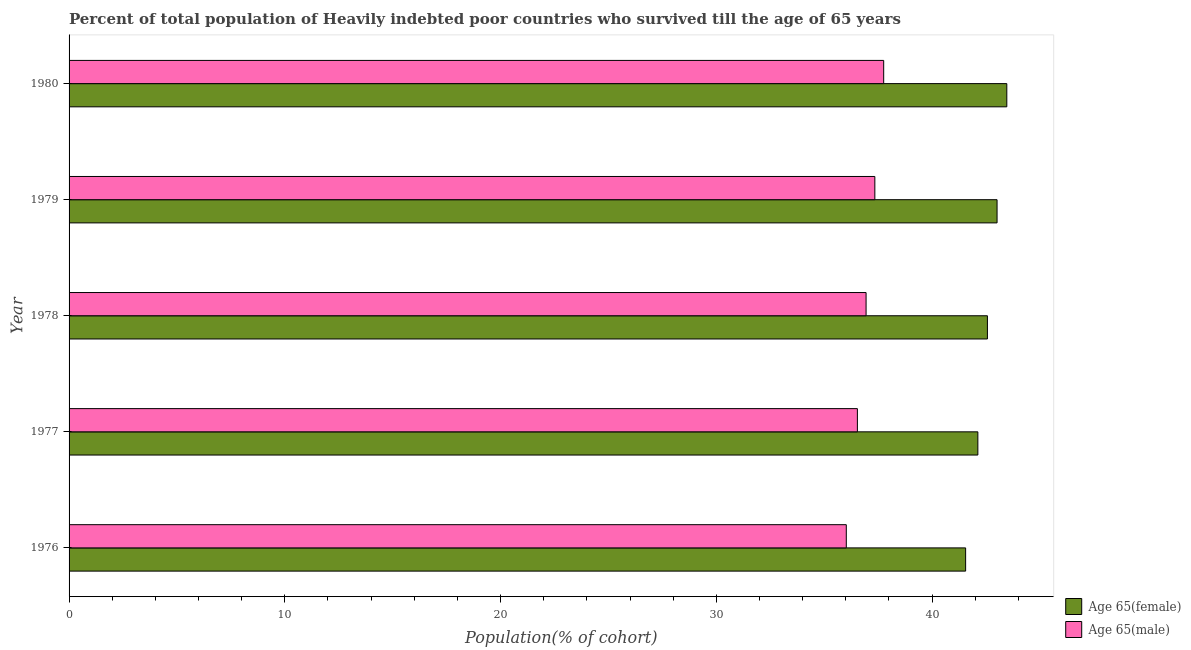How many bars are there on the 1st tick from the top?
Give a very brief answer. 2. How many bars are there on the 2nd tick from the bottom?
Give a very brief answer. 2. What is the label of the 3rd group of bars from the top?
Make the answer very short. 1978. In how many cases, is the number of bars for a given year not equal to the number of legend labels?
Your answer should be compact. 0. What is the percentage of male population who survived till age of 65 in 1977?
Keep it short and to the point. 36.54. Across all years, what is the maximum percentage of female population who survived till age of 65?
Provide a short and direct response. 43.46. Across all years, what is the minimum percentage of male population who survived till age of 65?
Give a very brief answer. 36.02. In which year was the percentage of male population who survived till age of 65 maximum?
Offer a terse response. 1980. In which year was the percentage of female population who survived till age of 65 minimum?
Your answer should be very brief. 1976. What is the total percentage of female population who survived till age of 65 in the graph?
Keep it short and to the point. 212.71. What is the difference between the percentage of male population who survived till age of 65 in 1977 and that in 1979?
Make the answer very short. -0.81. What is the difference between the percentage of male population who survived till age of 65 in 1979 and the percentage of female population who survived till age of 65 in 1980?
Provide a succinct answer. -6.12. What is the average percentage of male population who survived till age of 65 per year?
Provide a succinct answer. 36.92. In the year 1976, what is the difference between the percentage of male population who survived till age of 65 and percentage of female population who survived till age of 65?
Give a very brief answer. -5.53. What is the ratio of the percentage of male population who survived till age of 65 in 1976 to that in 1977?
Ensure brevity in your answer.  0.99. Is the percentage of male population who survived till age of 65 in 1977 less than that in 1978?
Your answer should be compact. Yes. Is the difference between the percentage of male population who survived till age of 65 in 1979 and 1980 greater than the difference between the percentage of female population who survived till age of 65 in 1979 and 1980?
Your answer should be compact. Yes. What is the difference between the highest and the second highest percentage of female population who survived till age of 65?
Ensure brevity in your answer.  0.45. What is the difference between the highest and the lowest percentage of female population who survived till age of 65?
Your answer should be very brief. 1.91. In how many years, is the percentage of male population who survived till age of 65 greater than the average percentage of male population who survived till age of 65 taken over all years?
Your answer should be compact. 3. Is the sum of the percentage of male population who survived till age of 65 in 1978 and 1980 greater than the maximum percentage of female population who survived till age of 65 across all years?
Keep it short and to the point. Yes. What does the 2nd bar from the top in 1980 represents?
Provide a succinct answer. Age 65(female). What does the 2nd bar from the bottom in 1976 represents?
Provide a short and direct response. Age 65(male). Are all the bars in the graph horizontal?
Give a very brief answer. Yes. How many years are there in the graph?
Provide a succinct answer. 5. Where does the legend appear in the graph?
Keep it short and to the point. Bottom right. How many legend labels are there?
Offer a very short reply. 2. What is the title of the graph?
Ensure brevity in your answer.  Percent of total population of Heavily indebted poor countries who survived till the age of 65 years. Does "Urban agglomerations" appear as one of the legend labels in the graph?
Keep it short and to the point. No. What is the label or title of the X-axis?
Keep it short and to the point. Population(% of cohort). What is the Population(% of cohort) of Age 65(female) in 1976?
Give a very brief answer. 41.55. What is the Population(% of cohort) in Age 65(male) in 1976?
Provide a succinct answer. 36.02. What is the Population(% of cohort) in Age 65(female) in 1977?
Your response must be concise. 42.12. What is the Population(% of cohort) in Age 65(male) in 1977?
Give a very brief answer. 36.54. What is the Population(% of cohort) of Age 65(female) in 1978?
Provide a short and direct response. 42.56. What is the Population(% of cohort) in Age 65(male) in 1978?
Your answer should be compact. 36.94. What is the Population(% of cohort) of Age 65(female) in 1979?
Make the answer very short. 43.01. What is the Population(% of cohort) in Age 65(male) in 1979?
Provide a short and direct response. 37.35. What is the Population(% of cohort) in Age 65(female) in 1980?
Make the answer very short. 43.46. What is the Population(% of cohort) in Age 65(male) in 1980?
Make the answer very short. 37.76. Across all years, what is the maximum Population(% of cohort) in Age 65(female)?
Your answer should be compact. 43.46. Across all years, what is the maximum Population(% of cohort) in Age 65(male)?
Provide a succinct answer. 37.76. Across all years, what is the minimum Population(% of cohort) of Age 65(female)?
Provide a succinct answer. 41.55. Across all years, what is the minimum Population(% of cohort) of Age 65(male)?
Your answer should be very brief. 36.02. What is the total Population(% of cohort) in Age 65(female) in the graph?
Your answer should be compact. 212.71. What is the total Population(% of cohort) of Age 65(male) in the graph?
Ensure brevity in your answer.  184.6. What is the difference between the Population(% of cohort) of Age 65(female) in 1976 and that in 1977?
Give a very brief answer. -0.57. What is the difference between the Population(% of cohort) of Age 65(male) in 1976 and that in 1977?
Ensure brevity in your answer.  -0.51. What is the difference between the Population(% of cohort) in Age 65(female) in 1976 and that in 1978?
Offer a very short reply. -1.01. What is the difference between the Population(% of cohort) in Age 65(male) in 1976 and that in 1978?
Your answer should be very brief. -0.92. What is the difference between the Population(% of cohort) in Age 65(female) in 1976 and that in 1979?
Your answer should be very brief. -1.46. What is the difference between the Population(% of cohort) of Age 65(male) in 1976 and that in 1979?
Your response must be concise. -1.32. What is the difference between the Population(% of cohort) in Age 65(female) in 1976 and that in 1980?
Offer a terse response. -1.91. What is the difference between the Population(% of cohort) of Age 65(male) in 1976 and that in 1980?
Ensure brevity in your answer.  -1.73. What is the difference between the Population(% of cohort) in Age 65(female) in 1977 and that in 1978?
Ensure brevity in your answer.  -0.44. What is the difference between the Population(% of cohort) of Age 65(male) in 1977 and that in 1978?
Your answer should be very brief. -0.4. What is the difference between the Population(% of cohort) in Age 65(female) in 1977 and that in 1979?
Provide a succinct answer. -0.89. What is the difference between the Population(% of cohort) in Age 65(male) in 1977 and that in 1979?
Your answer should be very brief. -0.81. What is the difference between the Population(% of cohort) of Age 65(female) in 1977 and that in 1980?
Provide a succinct answer. -1.34. What is the difference between the Population(% of cohort) of Age 65(male) in 1977 and that in 1980?
Offer a terse response. -1.22. What is the difference between the Population(% of cohort) in Age 65(female) in 1978 and that in 1979?
Give a very brief answer. -0.45. What is the difference between the Population(% of cohort) in Age 65(male) in 1978 and that in 1979?
Make the answer very short. -0.41. What is the difference between the Population(% of cohort) in Age 65(female) in 1978 and that in 1980?
Your answer should be compact. -0.9. What is the difference between the Population(% of cohort) in Age 65(male) in 1978 and that in 1980?
Offer a very short reply. -0.82. What is the difference between the Population(% of cohort) in Age 65(female) in 1979 and that in 1980?
Make the answer very short. -0.45. What is the difference between the Population(% of cohort) of Age 65(male) in 1979 and that in 1980?
Provide a short and direct response. -0.41. What is the difference between the Population(% of cohort) in Age 65(female) in 1976 and the Population(% of cohort) in Age 65(male) in 1977?
Make the answer very short. 5.02. What is the difference between the Population(% of cohort) in Age 65(female) in 1976 and the Population(% of cohort) in Age 65(male) in 1978?
Offer a very short reply. 4.61. What is the difference between the Population(% of cohort) in Age 65(female) in 1976 and the Population(% of cohort) in Age 65(male) in 1979?
Your response must be concise. 4.21. What is the difference between the Population(% of cohort) of Age 65(female) in 1976 and the Population(% of cohort) of Age 65(male) in 1980?
Your response must be concise. 3.8. What is the difference between the Population(% of cohort) of Age 65(female) in 1977 and the Population(% of cohort) of Age 65(male) in 1978?
Your response must be concise. 5.18. What is the difference between the Population(% of cohort) of Age 65(female) in 1977 and the Population(% of cohort) of Age 65(male) in 1979?
Keep it short and to the point. 4.77. What is the difference between the Population(% of cohort) in Age 65(female) in 1977 and the Population(% of cohort) in Age 65(male) in 1980?
Ensure brevity in your answer.  4.36. What is the difference between the Population(% of cohort) in Age 65(female) in 1978 and the Population(% of cohort) in Age 65(male) in 1979?
Your answer should be compact. 5.22. What is the difference between the Population(% of cohort) of Age 65(female) in 1978 and the Population(% of cohort) of Age 65(male) in 1980?
Give a very brief answer. 4.81. What is the difference between the Population(% of cohort) of Age 65(female) in 1979 and the Population(% of cohort) of Age 65(male) in 1980?
Give a very brief answer. 5.25. What is the average Population(% of cohort) in Age 65(female) per year?
Provide a short and direct response. 42.54. What is the average Population(% of cohort) in Age 65(male) per year?
Your answer should be very brief. 36.92. In the year 1976, what is the difference between the Population(% of cohort) in Age 65(female) and Population(% of cohort) in Age 65(male)?
Ensure brevity in your answer.  5.53. In the year 1977, what is the difference between the Population(% of cohort) in Age 65(female) and Population(% of cohort) in Age 65(male)?
Your answer should be compact. 5.58. In the year 1978, what is the difference between the Population(% of cohort) in Age 65(female) and Population(% of cohort) in Age 65(male)?
Provide a short and direct response. 5.62. In the year 1979, what is the difference between the Population(% of cohort) in Age 65(female) and Population(% of cohort) in Age 65(male)?
Ensure brevity in your answer.  5.67. In the year 1980, what is the difference between the Population(% of cohort) of Age 65(female) and Population(% of cohort) of Age 65(male)?
Your response must be concise. 5.71. What is the ratio of the Population(% of cohort) of Age 65(female) in 1976 to that in 1977?
Offer a terse response. 0.99. What is the ratio of the Population(% of cohort) of Age 65(male) in 1976 to that in 1977?
Your response must be concise. 0.99. What is the ratio of the Population(% of cohort) of Age 65(female) in 1976 to that in 1978?
Provide a succinct answer. 0.98. What is the ratio of the Population(% of cohort) of Age 65(male) in 1976 to that in 1978?
Offer a terse response. 0.98. What is the ratio of the Population(% of cohort) in Age 65(female) in 1976 to that in 1979?
Offer a terse response. 0.97. What is the ratio of the Population(% of cohort) of Age 65(male) in 1976 to that in 1979?
Give a very brief answer. 0.96. What is the ratio of the Population(% of cohort) in Age 65(female) in 1976 to that in 1980?
Your answer should be compact. 0.96. What is the ratio of the Population(% of cohort) of Age 65(male) in 1976 to that in 1980?
Provide a short and direct response. 0.95. What is the ratio of the Population(% of cohort) in Age 65(female) in 1977 to that in 1978?
Ensure brevity in your answer.  0.99. What is the ratio of the Population(% of cohort) of Age 65(male) in 1977 to that in 1978?
Ensure brevity in your answer.  0.99. What is the ratio of the Population(% of cohort) in Age 65(female) in 1977 to that in 1979?
Provide a short and direct response. 0.98. What is the ratio of the Population(% of cohort) of Age 65(male) in 1977 to that in 1979?
Offer a terse response. 0.98. What is the ratio of the Population(% of cohort) of Age 65(female) in 1977 to that in 1980?
Ensure brevity in your answer.  0.97. What is the ratio of the Population(% of cohort) of Age 65(male) in 1977 to that in 1980?
Keep it short and to the point. 0.97. What is the ratio of the Population(% of cohort) in Age 65(female) in 1978 to that in 1980?
Your response must be concise. 0.98. What is the ratio of the Population(% of cohort) of Age 65(male) in 1978 to that in 1980?
Offer a terse response. 0.98. What is the difference between the highest and the second highest Population(% of cohort) in Age 65(female)?
Offer a terse response. 0.45. What is the difference between the highest and the second highest Population(% of cohort) in Age 65(male)?
Your answer should be very brief. 0.41. What is the difference between the highest and the lowest Population(% of cohort) of Age 65(female)?
Keep it short and to the point. 1.91. What is the difference between the highest and the lowest Population(% of cohort) in Age 65(male)?
Ensure brevity in your answer.  1.73. 